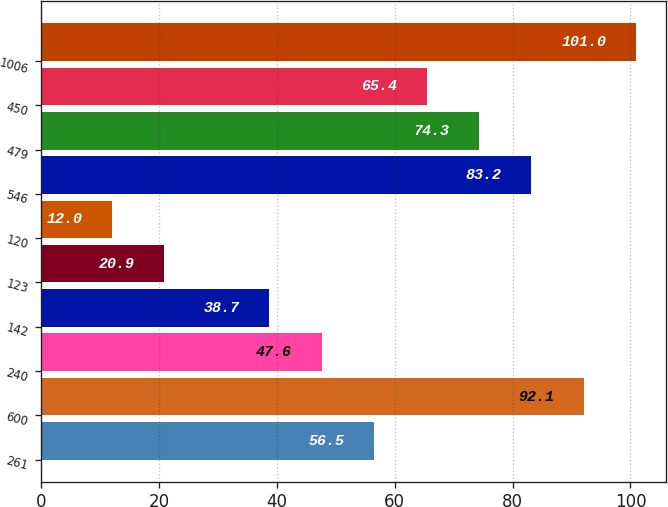<chart> <loc_0><loc_0><loc_500><loc_500><bar_chart><fcel>261<fcel>600<fcel>240<fcel>142<fcel>123<fcel>120<fcel>546<fcel>479<fcel>450<fcel>1006<nl><fcel>56.5<fcel>92.1<fcel>47.6<fcel>38.7<fcel>20.9<fcel>12<fcel>83.2<fcel>74.3<fcel>65.4<fcel>101<nl></chart> 